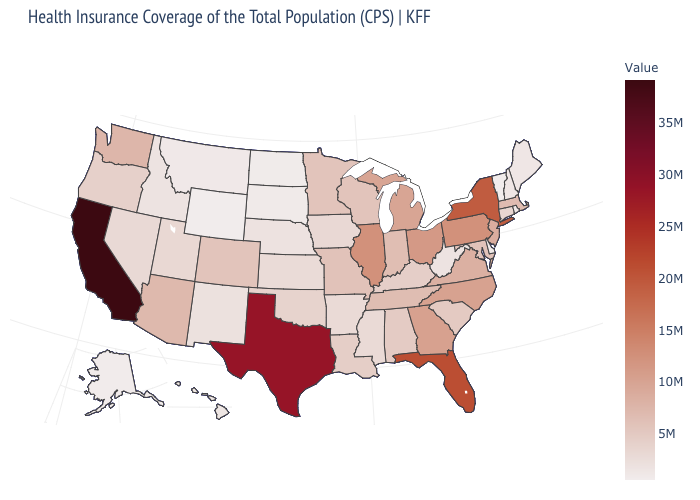Among the states that border Alabama , does Florida have the highest value?
Keep it brief. Yes. Does Hawaii have a lower value than Arizona?
Write a very short answer. Yes. Does New Hampshire have the lowest value in the Northeast?
Concise answer only. No. Which states have the highest value in the USA?
Give a very brief answer. California. Among the states that border Indiana , which have the highest value?
Give a very brief answer. Illinois. 